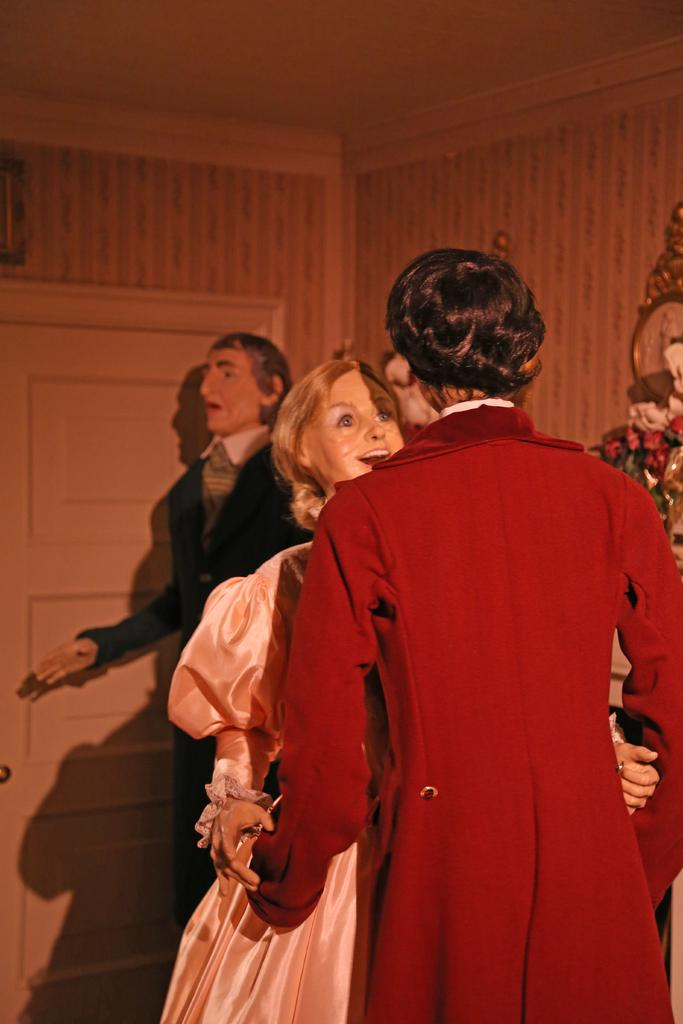What type of figures can be seen in the image? There are mannequins in the image. What is visible in the background of the image? There is a wall, a door, and other objects in the background of the image. What part of the building can be seen at the top of the image? The roof is visible at the top of the image. What type of blade is being used by the mannequins in the image? There are no blades present in the image; it features mannequins and various background elements. What type of poison is being used by the mannequins in the image? There is no poison present in the image; it features mannequins and various background elements. 